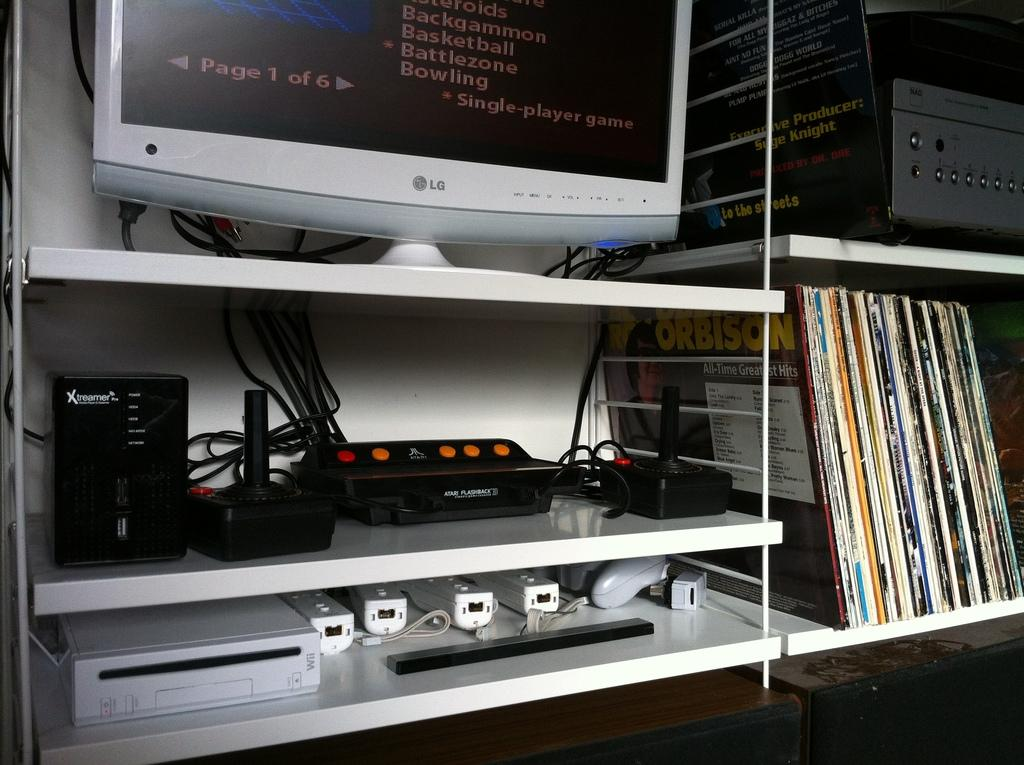<image>
Offer a succinct explanation of the picture presented. Roy Orbison's All Time Greatest Hits is among the records on the shelf unit. 